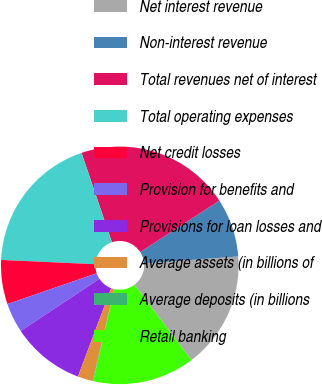Convert chart. <chart><loc_0><loc_0><loc_500><loc_500><pie_chart><fcel>Net interest revenue<fcel>Non-interest revenue<fcel>Total revenues net of interest<fcel>Total operating expenses<fcel>Net credit losses<fcel>Provision for benefits and<fcel>Provisions for loan losses and<fcel>Average assets (in billions of<fcel>Average deposits (in billions<fcel>Retail banking<nl><fcel>15.88%<fcel>7.98%<fcel>21.04%<fcel>19.06%<fcel>6.01%<fcel>4.03%<fcel>9.96%<fcel>2.06%<fcel>0.08%<fcel>13.9%<nl></chart> 